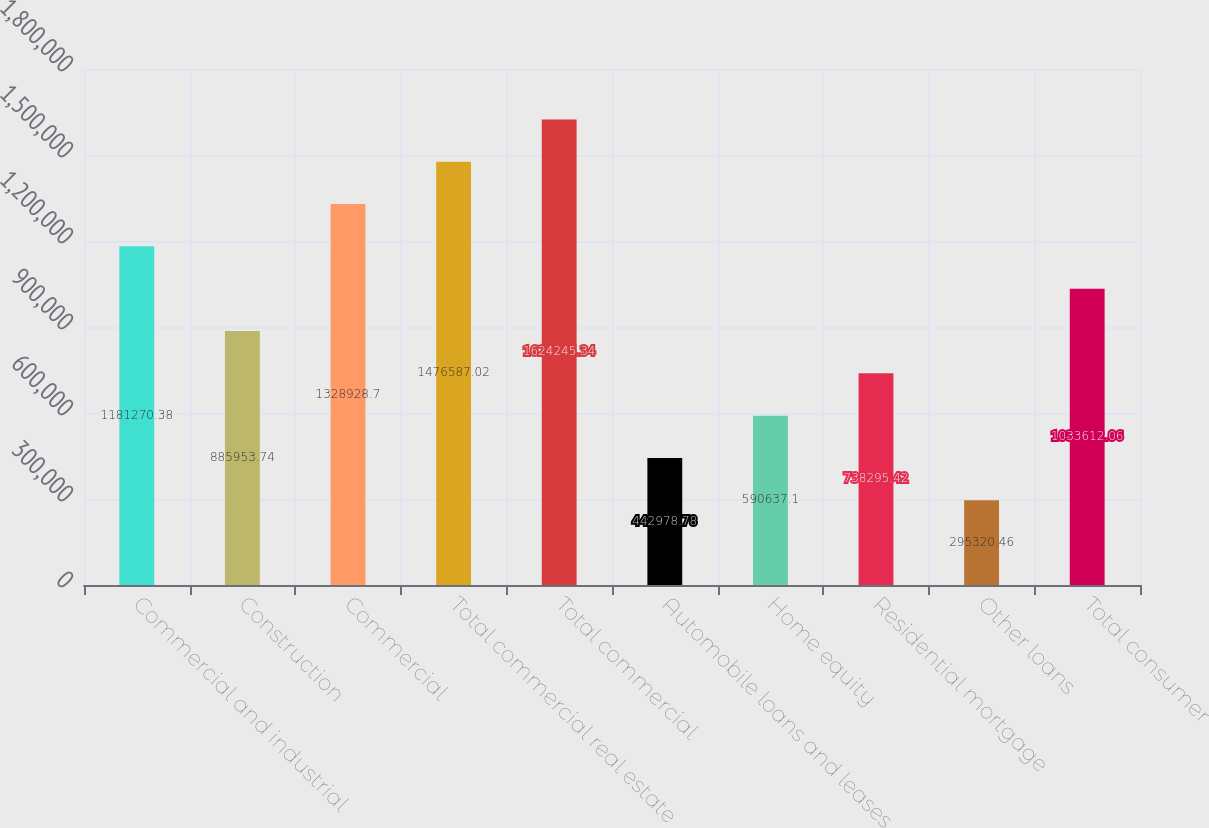<chart> <loc_0><loc_0><loc_500><loc_500><bar_chart><fcel>Commercial and industrial<fcel>Construction<fcel>Commercial<fcel>Total commercial real estate<fcel>Total commercial<fcel>Automobile loans and leases<fcel>Home equity<fcel>Residential mortgage<fcel>Other loans<fcel>Total consumer<nl><fcel>1.18127e+06<fcel>885954<fcel>1.32893e+06<fcel>1.47659e+06<fcel>1.62425e+06<fcel>442979<fcel>590637<fcel>738295<fcel>295320<fcel>1.03361e+06<nl></chart> 